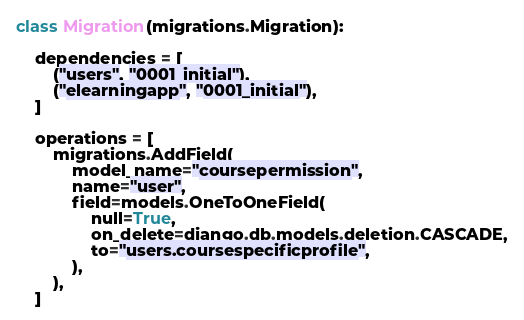<code> <loc_0><loc_0><loc_500><loc_500><_Python_>class Migration(migrations.Migration):

    dependencies = [
        ("users", "0001_initial"),
        ("elearningapp", "0001_initial"),
    ]

    operations = [
        migrations.AddField(
            model_name="coursepermission",
            name="user",
            field=models.OneToOneField(
                null=True,
                on_delete=django.db.models.deletion.CASCADE,
                to="users.coursespecificprofile",
            ),
        ),
    ]</code> 